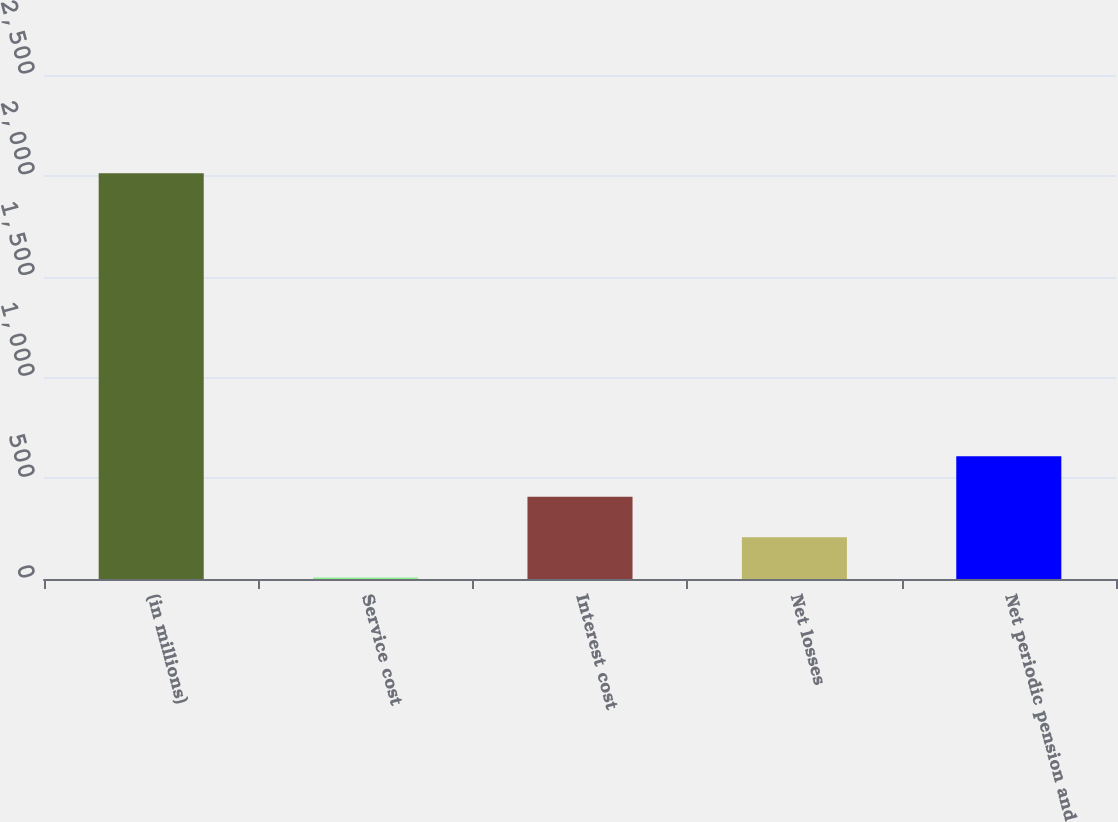Convert chart to OTSL. <chart><loc_0><loc_0><loc_500><loc_500><bar_chart><fcel>(in millions)<fcel>Service cost<fcel>Interest cost<fcel>Net losses<fcel>Net periodic pension and<nl><fcel>2013<fcel>7<fcel>408.2<fcel>207.6<fcel>608.8<nl></chart> 